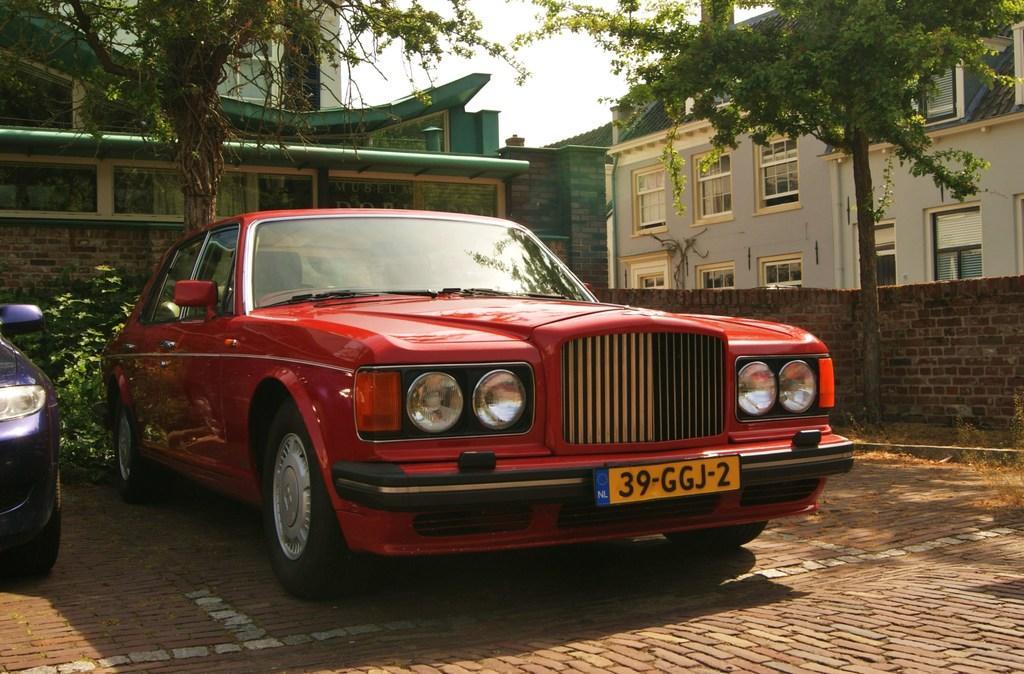In one or two sentences, can you explain what this image depicts? In this picture we can see the sky, trees and buildings. We can see a planet behind the cars. On the right side of the picture we can see the wall with bricks. At the bottom portion of the picture we can see the shadows on the floor. 